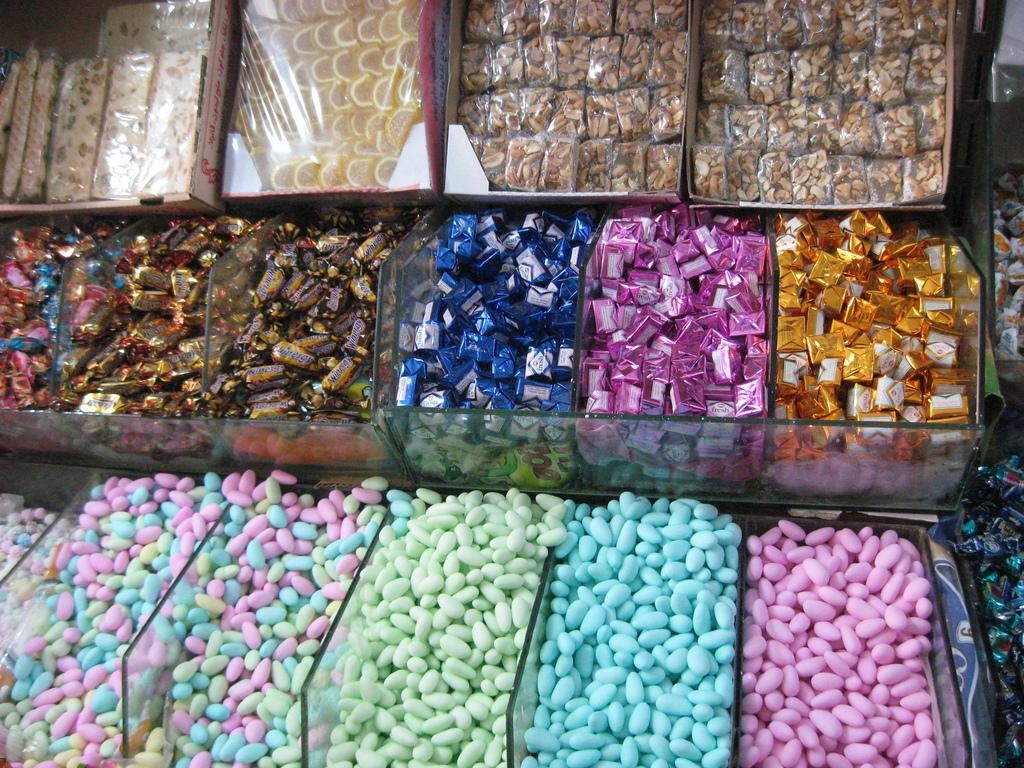What type of sweets can be seen in the image? There are candies in the image. How are the candies contained in the image? The candies are in a glass object. Where is the glass object located in the image? The glass object is in the foreground of the image. What type of fowl can be seen flying in the image? There are no fowl or planes visible in the image; it only features candies in a glass object. 